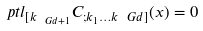<formula> <loc_0><loc_0><loc_500><loc_500>\ p t l _ { { [ } k _ { \ G d + 1 } } C _ { ; k _ { 1 } \dots k _ { \ } G d ] } ( x ) = 0</formula> 